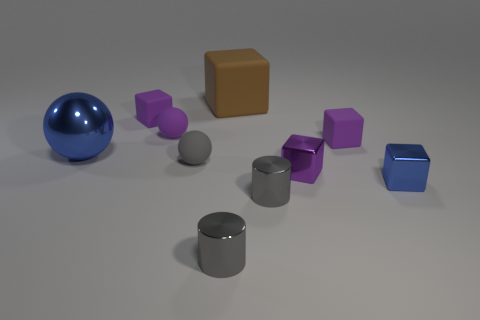There is a blue shiny object in front of the gray matte object; is it the same size as the big blue ball?
Your answer should be very brief. No. The big blue shiny object behind the gray cylinder that is in front of the gray metal thing that is on the right side of the large cube is what shape?
Make the answer very short. Sphere. How many objects are either small cyan shiny things or tiny objects in front of the purple metal object?
Your response must be concise. 3. How big is the purple cube left of the small purple shiny block?
Your response must be concise. Small. Do the big block and the small cube that is left of the brown rubber object have the same material?
Give a very brief answer. Yes. How many tiny blocks are right of the tiny purple rubber block that is right of the tiny matte object behind the tiny purple matte sphere?
Offer a terse response. 1. What number of brown things are either metal cylinders or big matte objects?
Ensure brevity in your answer.  1. The blue thing right of the gray rubber object has what shape?
Your answer should be very brief. Cube. The thing that is the same size as the metallic sphere is what color?
Your response must be concise. Brown. There is a tiny blue metallic object; is its shape the same as the large blue thing that is behind the purple metal thing?
Give a very brief answer. No. 